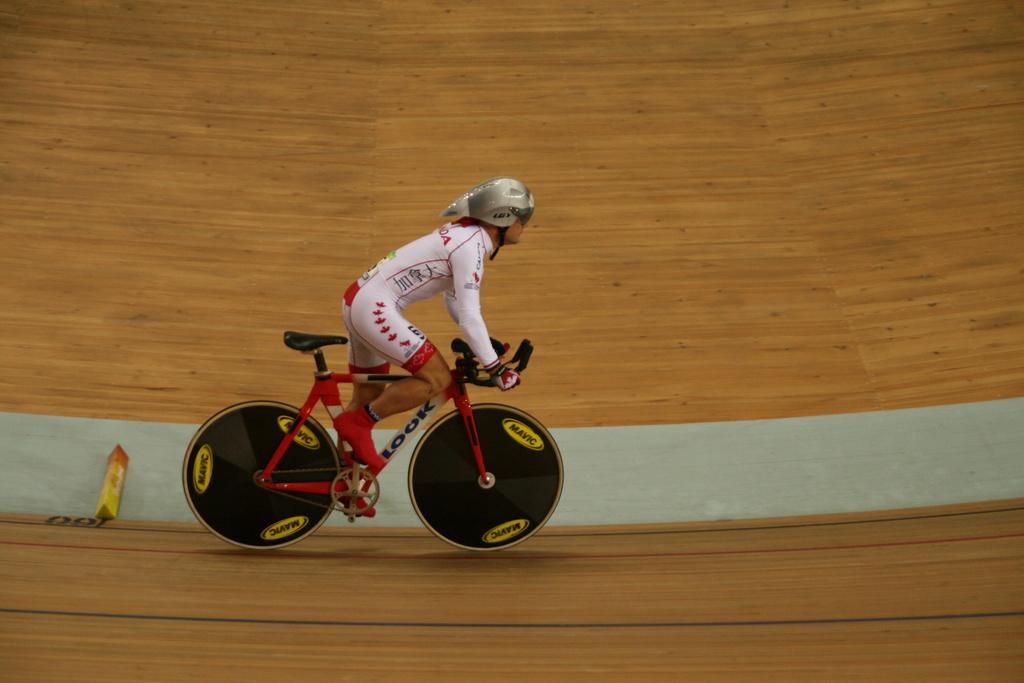Can you describe this image briefly? In this image there is a person with a helmet is riding a bicycle on the path. 